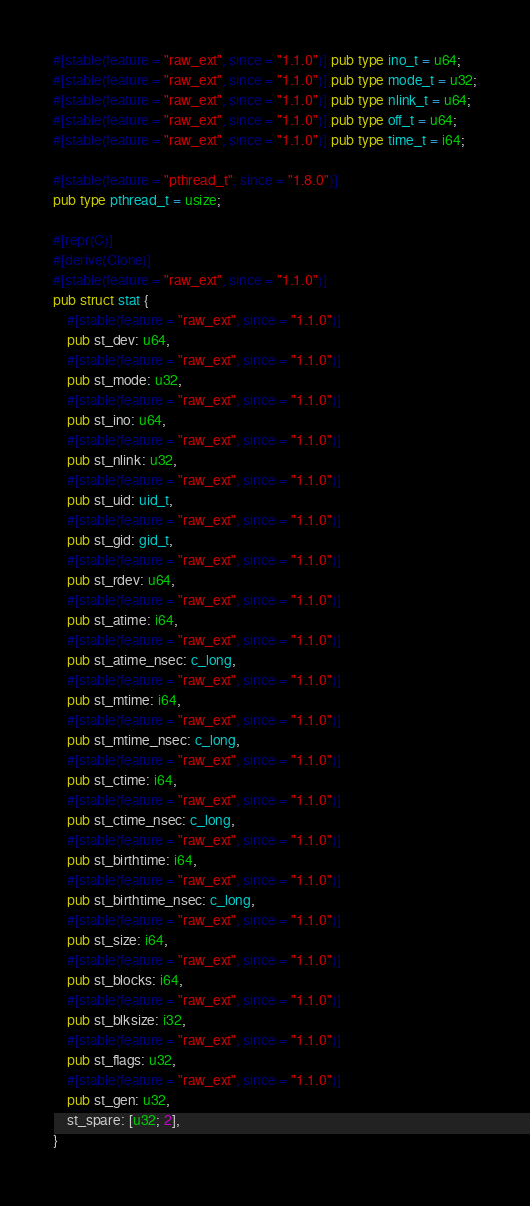<code> <loc_0><loc_0><loc_500><loc_500><_Rust_>#[stable(feature = "raw_ext", since = "1.1.0")] pub type ino_t = u64;
#[stable(feature = "raw_ext", since = "1.1.0")] pub type mode_t = u32;
#[stable(feature = "raw_ext", since = "1.1.0")] pub type nlink_t = u64;
#[stable(feature = "raw_ext", since = "1.1.0")] pub type off_t = u64;
#[stable(feature = "raw_ext", since = "1.1.0")] pub type time_t = i64;

#[stable(feature = "pthread_t", since = "1.8.0")]
pub type pthread_t = usize;

#[repr(C)]
#[derive(Clone)]
#[stable(feature = "raw_ext", since = "1.1.0")]
pub struct stat {
    #[stable(feature = "raw_ext", since = "1.1.0")]
    pub st_dev: u64,
    #[stable(feature = "raw_ext", since = "1.1.0")]
    pub st_mode: u32,
    #[stable(feature = "raw_ext", since = "1.1.0")]
    pub st_ino: u64,
    #[stable(feature = "raw_ext", since = "1.1.0")]
    pub st_nlink: u32,
    #[stable(feature = "raw_ext", since = "1.1.0")]
    pub st_uid: uid_t,
    #[stable(feature = "raw_ext", since = "1.1.0")]
    pub st_gid: gid_t,
    #[stable(feature = "raw_ext", since = "1.1.0")]
    pub st_rdev: u64,
    #[stable(feature = "raw_ext", since = "1.1.0")]
    pub st_atime: i64,
    #[stable(feature = "raw_ext", since = "1.1.0")]
    pub st_atime_nsec: c_long,
    #[stable(feature = "raw_ext", since = "1.1.0")]
    pub st_mtime: i64,
    #[stable(feature = "raw_ext", since = "1.1.0")]
    pub st_mtime_nsec: c_long,
    #[stable(feature = "raw_ext", since = "1.1.0")]
    pub st_ctime: i64,
    #[stable(feature = "raw_ext", since = "1.1.0")]
    pub st_ctime_nsec: c_long,
    #[stable(feature = "raw_ext", since = "1.1.0")]
    pub st_birthtime: i64,
    #[stable(feature = "raw_ext", since = "1.1.0")]
    pub st_birthtime_nsec: c_long,
    #[stable(feature = "raw_ext", since = "1.1.0")]
    pub st_size: i64,
    #[stable(feature = "raw_ext", since = "1.1.0")]
    pub st_blocks: i64,
    #[stable(feature = "raw_ext", since = "1.1.0")]
    pub st_blksize: i32,
    #[stable(feature = "raw_ext", since = "1.1.0")]
    pub st_flags: u32,
    #[stable(feature = "raw_ext", since = "1.1.0")]
    pub st_gen: u32,
    st_spare: [u32; 2],
}
</code> 